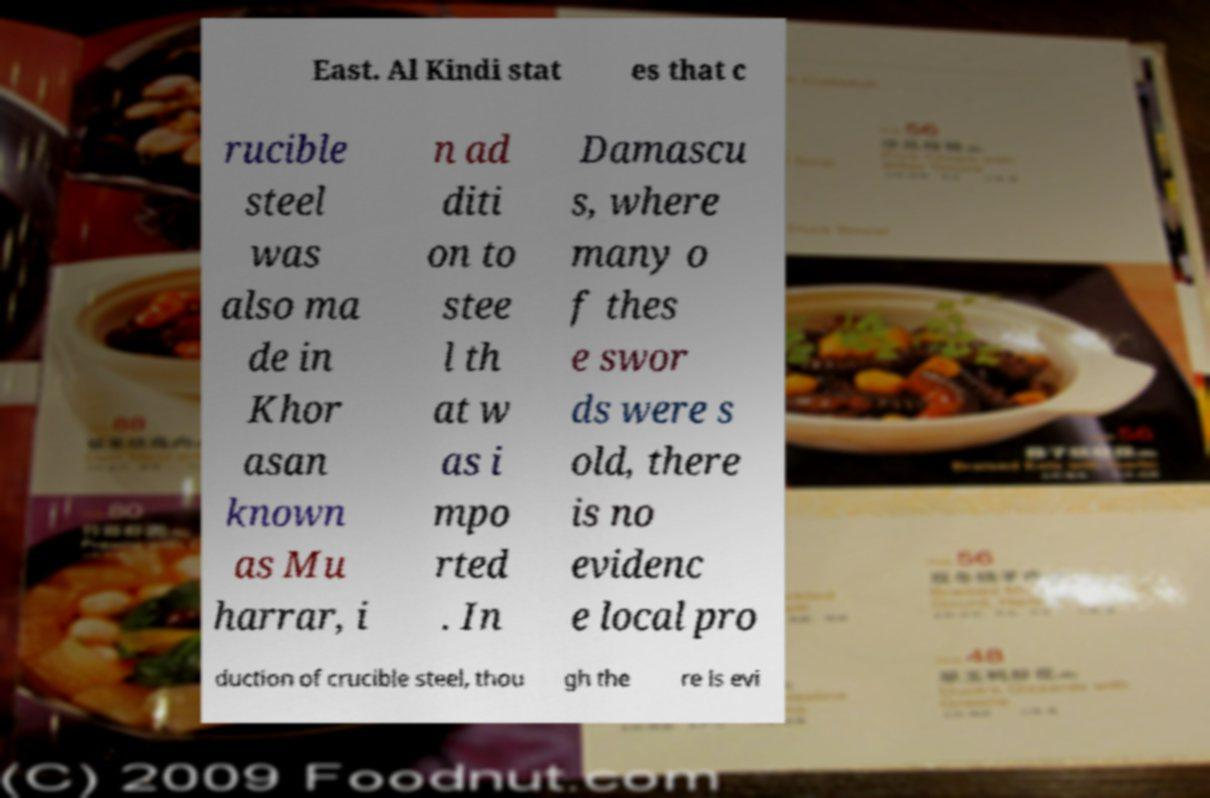For documentation purposes, I need the text within this image transcribed. Could you provide that? East. Al Kindi stat es that c rucible steel was also ma de in Khor asan known as Mu harrar, i n ad diti on to stee l th at w as i mpo rted . In Damascu s, where many o f thes e swor ds were s old, there is no evidenc e local pro duction of crucible steel, thou gh the re is evi 